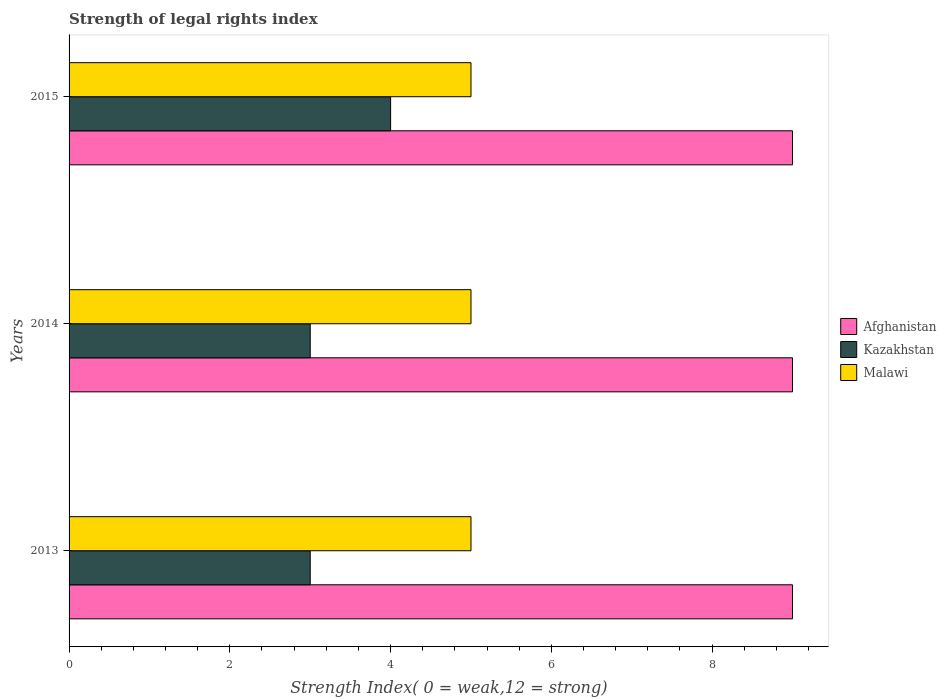Are the number of bars per tick equal to the number of legend labels?
Provide a succinct answer. Yes. Are the number of bars on each tick of the Y-axis equal?
Offer a very short reply. Yes. How many bars are there on the 1st tick from the top?
Your answer should be compact. 3. How many bars are there on the 1st tick from the bottom?
Ensure brevity in your answer.  3. What is the label of the 1st group of bars from the top?
Keep it short and to the point. 2015. What is the strength index in Kazakhstan in 2015?
Ensure brevity in your answer.  4. Across all years, what is the maximum strength index in Kazakhstan?
Provide a short and direct response. 4. Across all years, what is the minimum strength index in Afghanistan?
Make the answer very short. 9. In which year was the strength index in Afghanistan minimum?
Your answer should be compact. 2013. What is the total strength index in Malawi in the graph?
Keep it short and to the point. 15. What is the difference between the strength index in Kazakhstan in 2013 and that in 2015?
Your answer should be compact. -1. In the year 2014, what is the difference between the strength index in Kazakhstan and strength index in Malawi?
Offer a very short reply. -2. What is the ratio of the strength index in Malawi in 2013 to that in 2015?
Keep it short and to the point. 1. Is the strength index in Afghanistan in 2014 less than that in 2015?
Your response must be concise. No. What is the difference between the highest and the second highest strength index in Malawi?
Offer a very short reply. 0. What is the difference between the highest and the lowest strength index in Malawi?
Offer a terse response. 0. In how many years, is the strength index in Kazakhstan greater than the average strength index in Kazakhstan taken over all years?
Your answer should be compact. 1. What does the 3rd bar from the top in 2014 represents?
Ensure brevity in your answer.  Afghanistan. What does the 3rd bar from the bottom in 2014 represents?
Ensure brevity in your answer.  Malawi. Are all the bars in the graph horizontal?
Give a very brief answer. Yes. Does the graph contain any zero values?
Give a very brief answer. No. Does the graph contain grids?
Keep it short and to the point. No. Where does the legend appear in the graph?
Give a very brief answer. Center right. What is the title of the graph?
Offer a very short reply. Strength of legal rights index. What is the label or title of the X-axis?
Ensure brevity in your answer.  Strength Index( 0 = weak,12 = strong). What is the Strength Index( 0 = weak,12 = strong) in Afghanistan in 2013?
Your answer should be very brief. 9. What is the Strength Index( 0 = weak,12 = strong) in Malawi in 2013?
Offer a very short reply. 5. What is the Strength Index( 0 = weak,12 = strong) in Malawi in 2015?
Provide a short and direct response. 5. Across all years, what is the maximum Strength Index( 0 = weak,12 = strong) in Afghanistan?
Offer a terse response. 9. Across all years, what is the maximum Strength Index( 0 = weak,12 = strong) in Malawi?
Keep it short and to the point. 5. Across all years, what is the minimum Strength Index( 0 = weak,12 = strong) of Kazakhstan?
Provide a succinct answer. 3. What is the total Strength Index( 0 = weak,12 = strong) of Afghanistan in the graph?
Your answer should be compact. 27. What is the total Strength Index( 0 = weak,12 = strong) in Kazakhstan in the graph?
Offer a very short reply. 10. What is the difference between the Strength Index( 0 = weak,12 = strong) of Afghanistan in 2013 and that in 2014?
Your answer should be compact. 0. What is the difference between the Strength Index( 0 = weak,12 = strong) of Malawi in 2013 and that in 2014?
Keep it short and to the point. 0. What is the difference between the Strength Index( 0 = weak,12 = strong) in Afghanistan in 2014 and that in 2015?
Your answer should be very brief. 0. What is the difference between the Strength Index( 0 = weak,12 = strong) of Afghanistan in 2013 and the Strength Index( 0 = weak,12 = strong) of Kazakhstan in 2014?
Provide a succinct answer. 6. What is the difference between the Strength Index( 0 = weak,12 = strong) in Afghanistan in 2013 and the Strength Index( 0 = weak,12 = strong) in Malawi in 2014?
Provide a succinct answer. 4. What is the difference between the Strength Index( 0 = weak,12 = strong) in Afghanistan in 2013 and the Strength Index( 0 = weak,12 = strong) in Kazakhstan in 2015?
Ensure brevity in your answer.  5. What is the difference between the Strength Index( 0 = weak,12 = strong) of Afghanistan in 2013 and the Strength Index( 0 = weak,12 = strong) of Malawi in 2015?
Offer a very short reply. 4. In the year 2013, what is the difference between the Strength Index( 0 = weak,12 = strong) of Afghanistan and Strength Index( 0 = weak,12 = strong) of Kazakhstan?
Offer a very short reply. 6. In the year 2013, what is the difference between the Strength Index( 0 = weak,12 = strong) of Afghanistan and Strength Index( 0 = weak,12 = strong) of Malawi?
Your response must be concise. 4. In the year 2014, what is the difference between the Strength Index( 0 = weak,12 = strong) in Afghanistan and Strength Index( 0 = weak,12 = strong) in Kazakhstan?
Offer a terse response. 6. In the year 2015, what is the difference between the Strength Index( 0 = weak,12 = strong) of Afghanistan and Strength Index( 0 = weak,12 = strong) of Kazakhstan?
Provide a short and direct response. 5. In the year 2015, what is the difference between the Strength Index( 0 = weak,12 = strong) in Afghanistan and Strength Index( 0 = weak,12 = strong) in Malawi?
Provide a short and direct response. 4. In the year 2015, what is the difference between the Strength Index( 0 = weak,12 = strong) of Kazakhstan and Strength Index( 0 = weak,12 = strong) of Malawi?
Give a very brief answer. -1. What is the ratio of the Strength Index( 0 = weak,12 = strong) of Afghanistan in 2013 to that in 2014?
Offer a very short reply. 1. What is the ratio of the Strength Index( 0 = weak,12 = strong) in Kazakhstan in 2013 to that in 2014?
Provide a succinct answer. 1. What is the ratio of the Strength Index( 0 = weak,12 = strong) in Malawi in 2013 to that in 2014?
Offer a terse response. 1. What is the ratio of the Strength Index( 0 = weak,12 = strong) in Kazakhstan in 2013 to that in 2015?
Provide a succinct answer. 0.75. What is the ratio of the Strength Index( 0 = weak,12 = strong) of Malawi in 2013 to that in 2015?
Your answer should be very brief. 1. What is the ratio of the Strength Index( 0 = weak,12 = strong) of Kazakhstan in 2014 to that in 2015?
Ensure brevity in your answer.  0.75. What is the ratio of the Strength Index( 0 = weak,12 = strong) in Malawi in 2014 to that in 2015?
Your response must be concise. 1. What is the difference between the highest and the second highest Strength Index( 0 = weak,12 = strong) of Afghanistan?
Your answer should be very brief. 0. What is the difference between the highest and the second highest Strength Index( 0 = weak,12 = strong) in Malawi?
Offer a very short reply. 0. What is the difference between the highest and the lowest Strength Index( 0 = weak,12 = strong) in Afghanistan?
Offer a terse response. 0. What is the difference between the highest and the lowest Strength Index( 0 = weak,12 = strong) in Kazakhstan?
Ensure brevity in your answer.  1. 